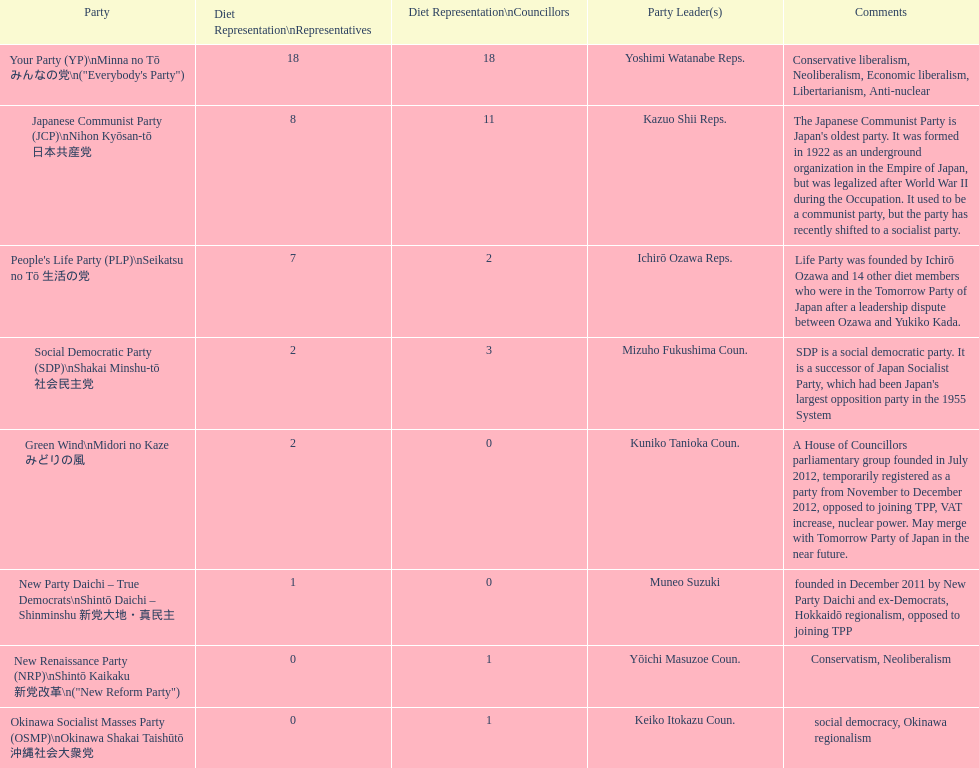How many party leaders can the people's life party have at most? 1. 